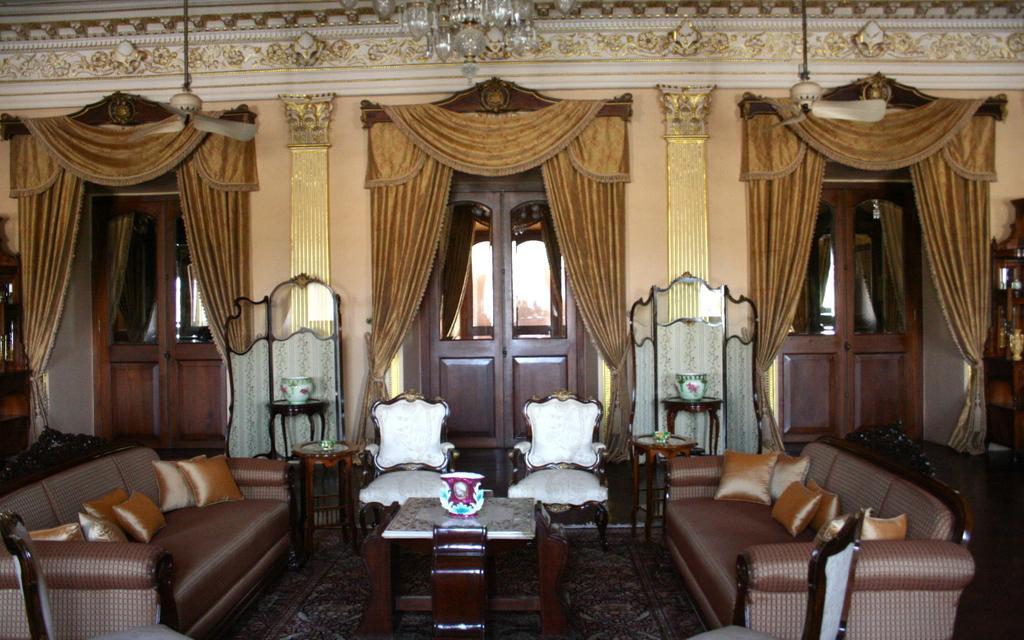Please provide a concise description of this image. in a room there is a table, sofa, chairs, doors and curtains. at the top there is a chandelier. 